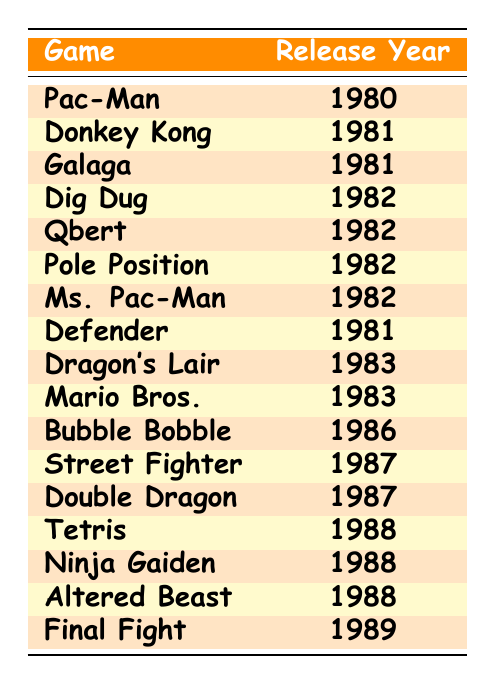What's the release year of Pac-Man? Pac-Man is listed in the table with the release year next to it. It shows that Pac-Man was released in 1980.
Answer: 1980 Which games were released in 1982? The table shows several games that are highlighted with the year 1982. Listing them shows that Dig Dug, Qbert, Pole Position, and Ms. Pac-Man were all released in 1982.
Answer: Dig Dug, Qbert, Pole Position, Ms. Pac-Man How many games were released in 1981? By reviewing the table, I count the games listed with the year 1981. The games are Donkey Kong, Galaga, and Defender. Thus, there are three games released in that year.
Answer: 3 Is Bubble Bobble the only game released in 1986? Checking the table, it reveals that Bubble Bobble is the only game listed for the year 1986, confirming that there are no other games listed for that year.
Answer: Yes What is the earliest release year among the listed games? The earliest release year is found by looking at the earliest date in the release years listed. Pac-Man is the first game, released in 1980.
Answer: 1980 Which game was released immediately after Donkey Kong? To find the game released after Donkey Kong, I look at the release year for Donkey Kong, which is 1981, and find the next game released, which is Galaga, also released in 1981. This means they were released in the same year.
Answer: Galaga How many years apart are the releases of Final Fight and Pac-Man? To calculate the difference, I subtract the release year of Pac-Man (1980) from Final Fight (1989), resulting in a difference of 9 years.
Answer: 9 years Are there more games released in the 1980s or the 1970s according to this table? Since the table only includes release years beginning from 1980, all the games are from the '80s, while there are no games from the 70s. As a result, there are more games in the '80s than in the '70s.
Answer: 80s What percentage of the games were released in 1982? Out of the total 15 games, four were released in 1982. To find the percentage, I calculate (4/15) * 100, which equals approx 26.67%.
Answer: 26.67% Which of the games listed was released last? To determine the last release, I review the table, and I see Final Fight, released in 1989, is the most recent game.
Answer: Final Fight 